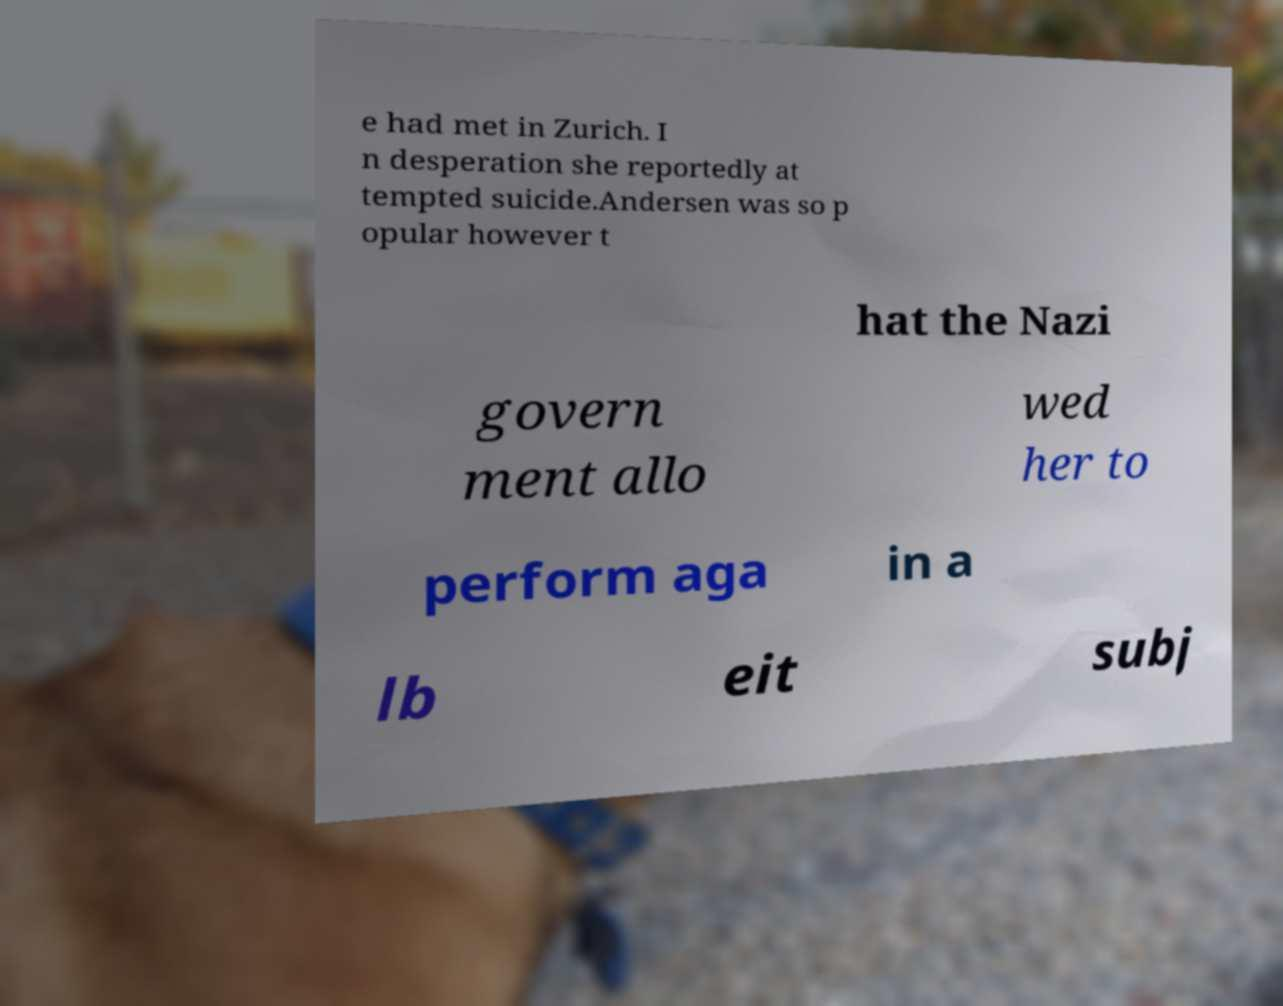There's text embedded in this image that I need extracted. Can you transcribe it verbatim? e had met in Zurich. I n desperation she reportedly at tempted suicide.Andersen was so p opular however t hat the Nazi govern ment allo wed her to perform aga in a lb eit subj 